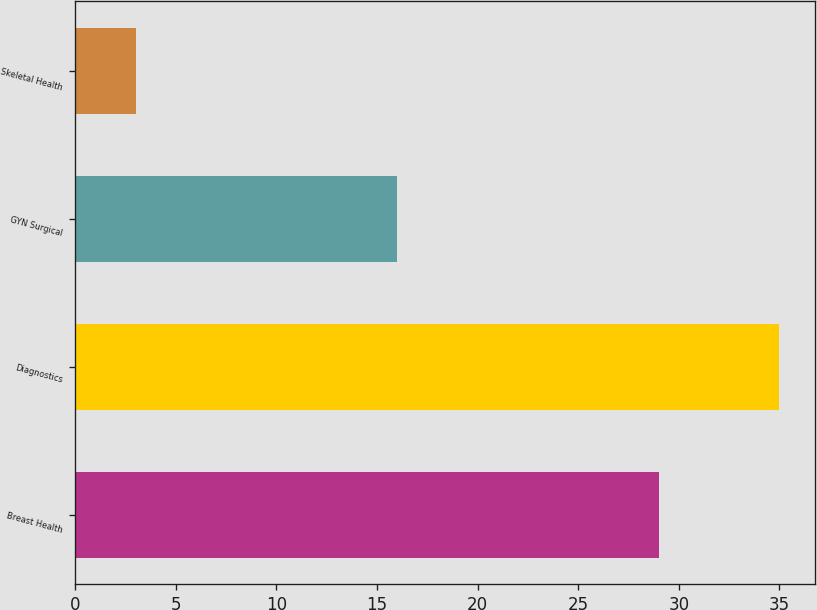Convert chart to OTSL. <chart><loc_0><loc_0><loc_500><loc_500><bar_chart><fcel>Breast Health<fcel>Diagnostics<fcel>GYN Surgical<fcel>Skeletal Health<nl><fcel>29<fcel>35<fcel>16<fcel>3<nl></chart> 